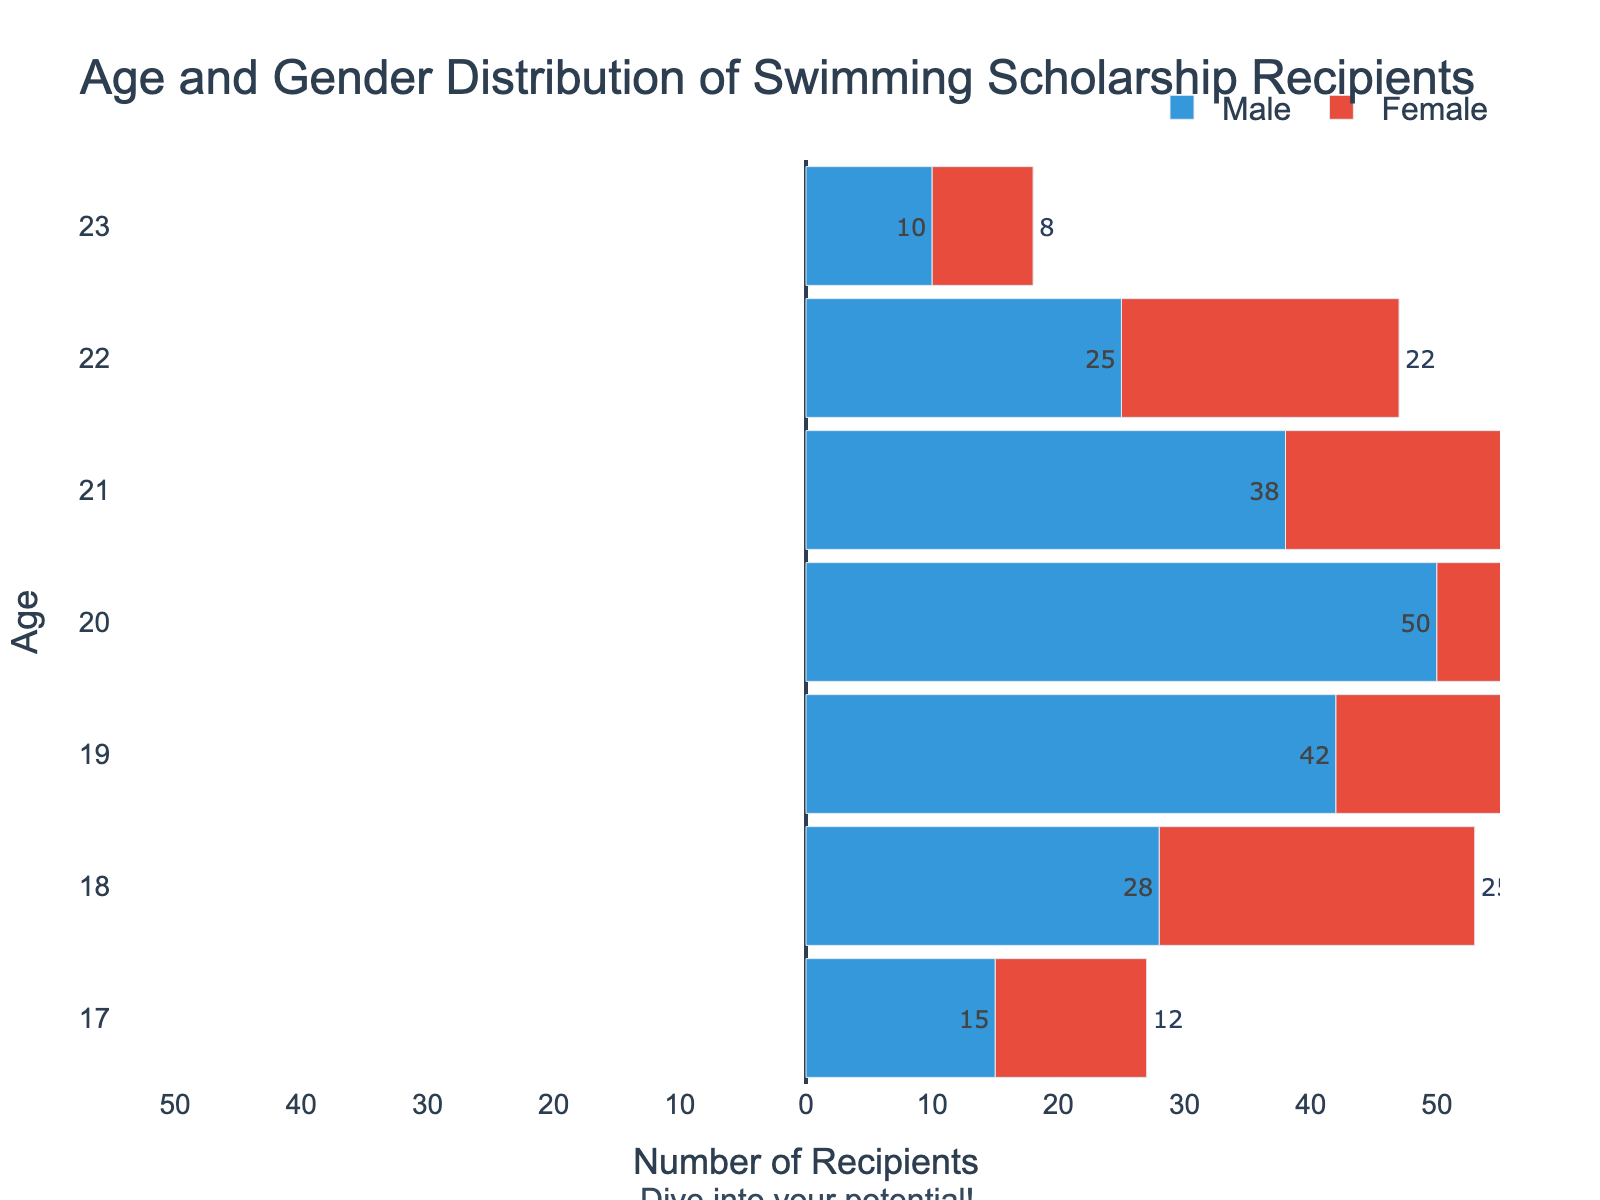What is the title of the figure? The title is at the top of the figure and reads, "Age and Gender Distribution of Swimming Scholarship Recipients"
Answer: Age and Gender Distribution of Swimming Scholarship Recipients How many age groups are represented in the figure? The ages are listed on the y-axis, and they range from 17 to 23, inclusive. So there are 7 age groups.
Answer: 7 Which age group has the highest number of male recipients? By comparing the lengths of the blue bars (male recipients) corresponding to each age on the y-axis, the bar for age 20 is the longest, indicating the highest number of male recipients.
Answer: Age 20 How does the number of female recipients aged 20 compare to the number of male recipients aged 20? The bar for female recipients at age 20 is shorter than the bar for male recipients at age 20. Specifically, the figure shows 45 female recipients and 50 male recipients, so there are 5 fewer female recipients.
Answer: 5 fewer female recipients What is the total number of male recipients across all age groups? Sum the absolute values of all the male recipients: 15 + 28 + 42 + 50 + 38 + 25 + 10 = 208
Answer: 208 What is the total number of female recipients across all age groups? Sum all the female recipients: 12 + 25 + 38 + 45 + 35 + 22 + 8 = 185
Answer: 185 Which age group has the greatest total number of recipients (male and female combined)? Add the values for the male and female recipients for each age group:  
Age 17: 15 + 12 = 27  
Age 18: 28 + 25 = 53  
Age 19: 42 + 38 = 80  
Age 20: 50 + 45 = 95  
Age 21: 38 + 35 = 73  
Age 22: 25 + 22 = 47  
Age 23: 10 + 8 = 18  
The age group 20 has the greatest total with 95 recipients.
Answer: Age 20 Which gender has more recipients aged 22? Compare the absolute values for age 22: Male recipients total 25 and female recipients total 22. Since 25 > 22, males have more recipients aged 22.
Answer: Male What motivational quote is added to the figure? There is a text annotation below the figure that reads, "Dive into your potential!"
Answer: Dive into your potential! 